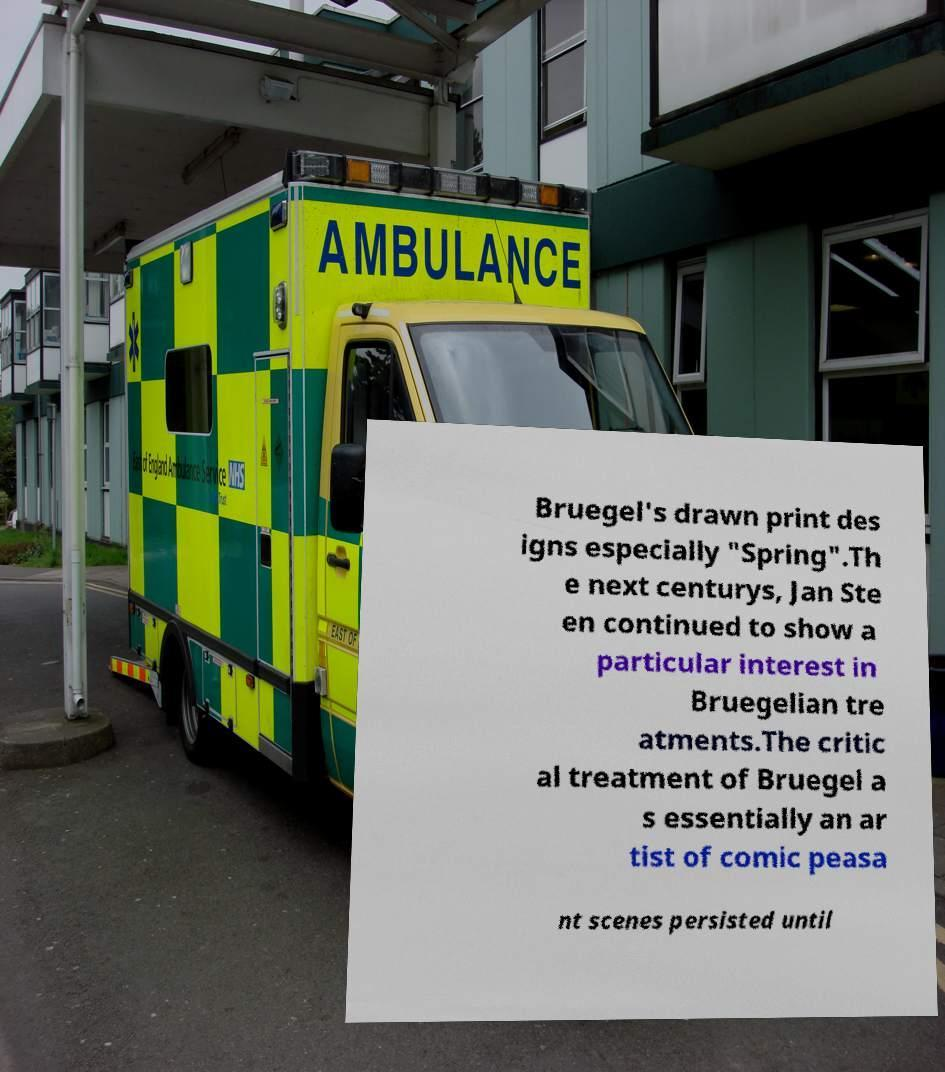Can you accurately transcribe the text from the provided image for me? Bruegel's drawn print des igns especially "Spring".Th e next centurys, Jan Ste en continued to show a particular interest in Bruegelian tre atments.The critic al treatment of Bruegel a s essentially an ar tist of comic peasa nt scenes persisted until 